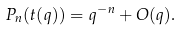Convert formula to latex. <formula><loc_0><loc_0><loc_500><loc_500>P _ { n } ( t ( q ) ) = q ^ { - n } + O ( q ) .</formula> 